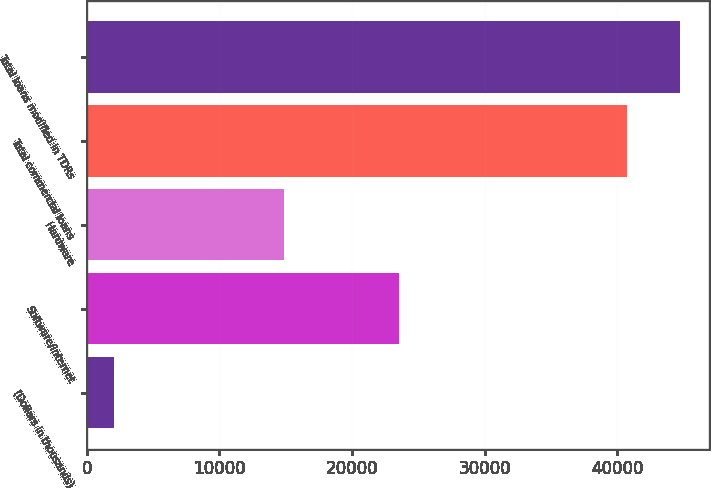Convert chart. <chart><loc_0><loc_0><loc_500><loc_500><bar_chart><fcel>(Dollars in thousands)<fcel>Software/internet<fcel>Hardware<fcel>Total commercial loans<fcel>Total loans modified in TDRs<nl><fcel>2016<fcel>23574<fcel>14870<fcel>40759<fcel>44711.9<nl></chart> 